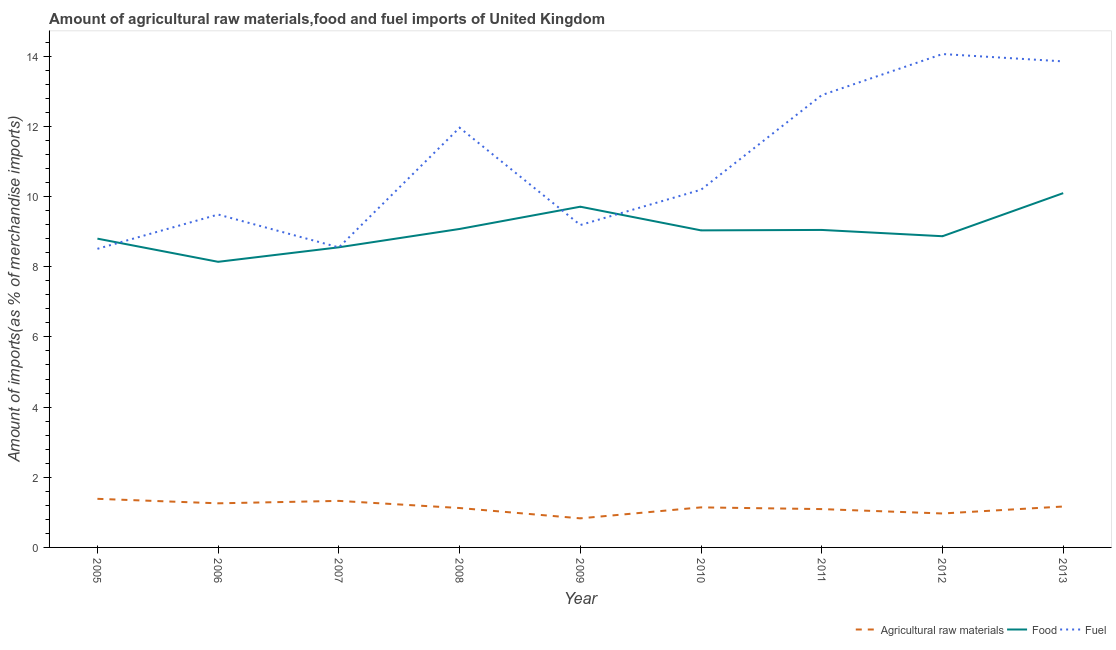Is the number of lines equal to the number of legend labels?
Keep it short and to the point. Yes. What is the percentage of food imports in 2007?
Your answer should be compact. 8.55. Across all years, what is the maximum percentage of food imports?
Keep it short and to the point. 10.1. Across all years, what is the minimum percentage of food imports?
Make the answer very short. 8.14. In which year was the percentage of food imports minimum?
Offer a very short reply. 2006. What is the total percentage of fuel imports in the graph?
Your response must be concise. 98.71. What is the difference between the percentage of food imports in 2006 and that in 2012?
Give a very brief answer. -0.73. What is the difference between the percentage of food imports in 2013 and the percentage of fuel imports in 2011?
Keep it short and to the point. -2.79. What is the average percentage of raw materials imports per year?
Provide a short and direct response. 1.14. In the year 2013, what is the difference between the percentage of raw materials imports and percentage of fuel imports?
Offer a very short reply. -12.69. In how many years, is the percentage of fuel imports greater than 2.8 %?
Provide a succinct answer. 9. What is the ratio of the percentage of food imports in 2010 to that in 2013?
Provide a succinct answer. 0.89. Is the percentage of fuel imports in 2007 less than that in 2008?
Provide a short and direct response. Yes. Is the difference between the percentage of fuel imports in 2009 and 2013 greater than the difference between the percentage of raw materials imports in 2009 and 2013?
Your answer should be compact. No. What is the difference between the highest and the second highest percentage of food imports?
Provide a succinct answer. 0.39. What is the difference between the highest and the lowest percentage of fuel imports?
Make the answer very short. 5.55. In how many years, is the percentage of fuel imports greater than the average percentage of fuel imports taken over all years?
Your answer should be compact. 4. Is the sum of the percentage of food imports in 2005 and 2007 greater than the maximum percentage of raw materials imports across all years?
Offer a very short reply. Yes. Is it the case that in every year, the sum of the percentage of raw materials imports and percentage of food imports is greater than the percentage of fuel imports?
Your answer should be very brief. No. How many lines are there?
Your response must be concise. 3. How many years are there in the graph?
Your response must be concise. 9. Does the graph contain grids?
Provide a short and direct response. No. How many legend labels are there?
Give a very brief answer. 3. What is the title of the graph?
Your answer should be very brief. Amount of agricultural raw materials,food and fuel imports of United Kingdom. What is the label or title of the X-axis?
Ensure brevity in your answer.  Year. What is the label or title of the Y-axis?
Provide a short and direct response. Amount of imports(as % of merchandise imports). What is the Amount of imports(as % of merchandise imports) of Agricultural raw materials in 2005?
Offer a very short reply. 1.39. What is the Amount of imports(as % of merchandise imports) of Food in 2005?
Make the answer very short. 8.8. What is the Amount of imports(as % of merchandise imports) of Fuel in 2005?
Give a very brief answer. 8.51. What is the Amount of imports(as % of merchandise imports) in Agricultural raw materials in 2006?
Keep it short and to the point. 1.26. What is the Amount of imports(as % of merchandise imports) of Food in 2006?
Your answer should be compact. 8.14. What is the Amount of imports(as % of merchandise imports) in Fuel in 2006?
Your answer should be compact. 9.49. What is the Amount of imports(as % of merchandise imports) in Agricultural raw materials in 2007?
Give a very brief answer. 1.33. What is the Amount of imports(as % of merchandise imports) of Food in 2007?
Keep it short and to the point. 8.55. What is the Amount of imports(as % of merchandise imports) in Fuel in 2007?
Your response must be concise. 8.55. What is the Amount of imports(as % of merchandise imports) of Agricultural raw materials in 2008?
Give a very brief answer. 1.12. What is the Amount of imports(as % of merchandise imports) of Food in 2008?
Keep it short and to the point. 9.08. What is the Amount of imports(as % of merchandise imports) of Fuel in 2008?
Ensure brevity in your answer.  11.96. What is the Amount of imports(as % of merchandise imports) in Agricultural raw materials in 2009?
Your response must be concise. 0.83. What is the Amount of imports(as % of merchandise imports) in Food in 2009?
Keep it short and to the point. 9.71. What is the Amount of imports(as % of merchandise imports) in Fuel in 2009?
Make the answer very short. 9.19. What is the Amount of imports(as % of merchandise imports) in Agricultural raw materials in 2010?
Give a very brief answer. 1.14. What is the Amount of imports(as % of merchandise imports) in Food in 2010?
Provide a succinct answer. 9.04. What is the Amount of imports(as % of merchandise imports) in Fuel in 2010?
Your response must be concise. 10.2. What is the Amount of imports(as % of merchandise imports) of Agricultural raw materials in 2011?
Give a very brief answer. 1.09. What is the Amount of imports(as % of merchandise imports) in Food in 2011?
Offer a terse response. 9.05. What is the Amount of imports(as % of merchandise imports) in Fuel in 2011?
Provide a succinct answer. 12.89. What is the Amount of imports(as % of merchandise imports) of Agricultural raw materials in 2012?
Keep it short and to the point. 0.97. What is the Amount of imports(as % of merchandise imports) in Food in 2012?
Make the answer very short. 8.87. What is the Amount of imports(as % of merchandise imports) in Fuel in 2012?
Your answer should be compact. 14.06. What is the Amount of imports(as % of merchandise imports) of Agricultural raw materials in 2013?
Provide a succinct answer. 1.17. What is the Amount of imports(as % of merchandise imports) in Food in 2013?
Offer a terse response. 10.1. What is the Amount of imports(as % of merchandise imports) in Fuel in 2013?
Provide a short and direct response. 13.85. Across all years, what is the maximum Amount of imports(as % of merchandise imports) in Agricultural raw materials?
Your response must be concise. 1.39. Across all years, what is the maximum Amount of imports(as % of merchandise imports) of Food?
Keep it short and to the point. 10.1. Across all years, what is the maximum Amount of imports(as % of merchandise imports) in Fuel?
Keep it short and to the point. 14.06. Across all years, what is the minimum Amount of imports(as % of merchandise imports) in Agricultural raw materials?
Your response must be concise. 0.83. Across all years, what is the minimum Amount of imports(as % of merchandise imports) of Food?
Provide a succinct answer. 8.14. Across all years, what is the minimum Amount of imports(as % of merchandise imports) in Fuel?
Give a very brief answer. 8.51. What is the total Amount of imports(as % of merchandise imports) in Agricultural raw materials in the graph?
Your response must be concise. 10.29. What is the total Amount of imports(as % of merchandise imports) of Food in the graph?
Make the answer very short. 81.34. What is the total Amount of imports(as % of merchandise imports) of Fuel in the graph?
Provide a short and direct response. 98.71. What is the difference between the Amount of imports(as % of merchandise imports) in Agricultural raw materials in 2005 and that in 2006?
Your answer should be compact. 0.13. What is the difference between the Amount of imports(as % of merchandise imports) in Food in 2005 and that in 2006?
Provide a succinct answer. 0.66. What is the difference between the Amount of imports(as % of merchandise imports) in Fuel in 2005 and that in 2006?
Your answer should be very brief. -0.98. What is the difference between the Amount of imports(as % of merchandise imports) of Agricultural raw materials in 2005 and that in 2007?
Provide a succinct answer. 0.06. What is the difference between the Amount of imports(as % of merchandise imports) in Food in 2005 and that in 2007?
Offer a terse response. 0.25. What is the difference between the Amount of imports(as % of merchandise imports) of Fuel in 2005 and that in 2007?
Provide a succinct answer. -0.04. What is the difference between the Amount of imports(as % of merchandise imports) in Agricultural raw materials in 2005 and that in 2008?
Your answer should be very brief. 0.26. What is the difference between the Amount of imports(as % of merchandise imports) in Food in 2005 and that in 2008?
Offer a terse response. -0.28. What is the difference between the Amount of imports(as % of merchandise imports) in Fuel in 2005 and that in 2008?
Provide a short and direct response. -3.45. What is the difference between the Amount of imports(as % of merchandise imports) in Agricultural raw materials in 2005 and that in 2009?
Keep it short and to the point. 0.56. What is the difference between the Amount of imports(as % of merchandise imports) of Food in 2005 and that in 2009?
Your answer should be very brief. -0.91. What is the difference between the Amount of imports(as % of merchandise imports) of Fuel in 2005 and that in 2009?
Offer a very short reply. -0.68. What is the difference between the Amount of imports(as % of merchandise imports) in Agricultural raw materials in 2005 and that in 2010?
Your answer should be very brief. 0.24. What is the difference between the Amount of imports(as % of merchandise imports) in Food in 2005 and that in 2010?
Your response must be concise. -0.24. What is the difference between the Amount of imports(as % of merchandise imports) in Fuel in 2005 and that in 2010?
Give a very brief answer. -1.68. What is the difference between the Amount of imports(as % of merchandise imports) in Agricultural raw materials in 2005 and that in 2011?
Provide a succinct answer. 0.29. What is the difference between the Amount of imports(as % of merchandise imports) of Food in 2005 and that in 2011?
Ensure brevity in your answer.  -0.25. What is the difference between the Amount of imports(as % of merchandise imports) of Fuel in 2005 and that in 2011?
Keep it short and to the point. -4.38. What is the difference between the Amount of imports(as % of merchandise imports) in Agricultural raw materials in 2005 and that in 2012?
Offer a terse response. 0.42. What is the difference between the Amount of imports(as % of merchandise imports) of Food in 2005 and that in 2012?
Your response must be concise. -0.07. What is the difference between the Amount of imports(as % of merchandise imports) in Fuel in 2005 and that in 2012?
Provide a short and direct response. -5.55. What is the difference between the Amount of imports(as % of merchandise imports) of Agricultural raw materials in 2005 and that in 2013?
Your answer should be very brief. 0.22. What is the difference between the Amount of imports(as % of merchandise imports) of Food in 2005 and that in 2013?
Give a very brief answer. -1.3. What is the difference between the Amount of imports(as % of merchandise imports) in Fuel in 2005 and that in 2013?
Give a very brief answer. -5.34. What is the difference between the Amount of imports(as % of merchandise imports) of Agricultural raw materials in 2006 and that in 2007?
Provide a short and direct response. -0.07. What is the difference between the Amount of imports(as % of merchandise imports) in Food in 2006 and that in 2007?
Provide a succinct answer. -0.41. What is the difference between the Amount of imports(as % of merchandise imports) in Fuel in 2006 and that in 2007?
Your response must be concise. 0.94. What is the difference between the Amount of imports(as % of merchandise imports) in Agricultural raw materials in 2006 and that in 2008?
Ensure brevity in your answer.  0.13. What is the difference between the Amount of imports(as % of merchandise imports) in Food in 2006 and that in 2008?
Offer a very short reply. -0.94. What is the difference between the Amount of imports(as % of merchandise imports) of Fuel in 2006 and that in 2008?
Give a very brief answer. -2.48. What is the difference between the Amount of imports(as % of merchandise imports) in Agricultural raw materials in 2006 and that in 2009?
Make the answer very short. 0.43. What is the difference between the Amount of imports(as % of merchandise imports) in Food in 2006 and that in 2009?
Offer a terse response. -1.57. What is the difference between the Amount of imports(as % of merchandise imports) of Fuel in 2006 and that in 2009?
Make the answer very short. 0.3. What is the difference between the Amount of imports(as % of merchandise imports) of Agricultural raw materials in 2006 and that in 2010?
Offer a terse response. 0.12. What is the difference between the Amount of imports(as % of merchandise imports) of Food in 2006 and that in 2010?
Make the answer very short. -0.9. What is the difference between the Amount of imports(as % of merchandise imports) in Fuel in 2006 and that in 2010?
Make the answer very short. -0.71. What is the difference between the Amount of imports(as % of merchandise imports) of Agricultural raw materials in 2006 and that in 2011?
Your answer should be compact. 0.16. What is the difference between the Amount of imports(as % of merchandise imports) in Food in 2006 and that in 2011?
Your answer should be compact. -0.91. What is the difference between the Amount of imports(as % of merchandise imports) in Fuel in 2006 and that in 2011?
Give a very brief answer. -3.4. What is the difference between the Amount of imports(as % of merchandise imports) of Agricultural raw materials in 2006 and that in 2012?
Provide a succinct answer. 0.29. What is the difference between the Amount of imports(as % of merchandise imports) of Food in 2006 and that in 2012?
Your answer should be very brief. -0.73. What is the difference between the Amount of imports(as % of merchandise imports) of Fuel in 2006 and that in 2012?
Keep it short and to the point. -4.57. What is the difference between the Amount of imports(as % of merchandise imports) of Agricultural raw materials in 2006 and that in 2013?
Your answer should be compact. 0.09. What is the difference between the Amount of imports(as % of merchandise imports) in Food in 2006 and that in 2013?
Ensure brevity in your answer.  -1.96. What is the difference between the Amount of imports(as % of merchandise imports) in Fuel in 2006 and that in 2013?
Your answer should be compact. -4.36. What is the difference between the Amount of imports(as % of merchandise imports) of Agricultural raw materials in 2007 and that in 2008?
Your response must be concise. 0.2. What is the difference between the Amount of imports(as % of merchandise imports) of Food in 2007 and that in 2008?
Ensure brevity in your answer.  -0.52. What is the difference between the Amount of imports(as % of merchandise imports) in Fuel in 2007 and that in 2008?
Provide a succinct answer. -3.41. What is the difference between the Amount of imports(as % of merchandise imports) in Agricultural raw materials in 2007 and that in 2009?
Provide a short and direct response. 0.5. What is the difference between the Amount of imports(as % of merchandise imports) in Food in 2007 and that in 2009?
Offer a very short reply. -1.16. What is the difference between the Amount of imports(as % of merchandise imports) of Fuel in 2007 and that in 2009?
Your answer should be very brief. -0.64. What is the difference between the Amount of imports(as % of merchandise imports) of Agricultural raw materials in 2007 and that in 2010?
Your answer should be very brief. 0.18. What is the difference between the Amount of imports(as % of merchandise imports) of Food in 2007 and that in 2010?
Provide a succinct answer. -0.48. What is the difference between the Amount of imports(as % of merchandise imports) in Fuel in 2007 and that in 2010?
Your answer should be compact. -1.64. What is the difference between the Amount of imports(as % of merchandise imports) of Agricultural raw materials in 2007 and that in 2011?
Offer a terse response. 0.23. What is the difference between the Amount of imports(as % of merchandise imports) of Food in 2007 and that in 2011?
Ensure brevity in your answer.  -0.5. What is the difference between the Amount of imports(as % of merchandise imports) in Fuel in 2007 and that in 2011?
Provide a short and direct response. -4.34. What is the difference between the Amount of imports(as % of merchandise imports) of Agricultural raw materials in 2007 and that in 2012?
Your response must be concise. 0.36. What is the difference between the Amount of imports(as % of merchandise imports) of Food in 2007 and that in 2012?
Make the answer very short. -0.32. What is the difference between the Amount of imports(as % of merchandise imports) of Fuel in 2007 and that in 2012?
Ensure brevity in your answer.  -5.51. What is the difference between the Amount of imports(as % of merchandise imports) of Agricultural raw materials in 2007 and that in 2013?
Your answer should be very brief. 0.16. What is the difference between the Amount of imports(as % of merchandise imports) of Food in 2007 and that in 2013?
Offer a terse response. -1.54. What is the difference between the Amount of imports(as % of merchandise imports) in Fuel in 2007 and that in 2013?
Ensure brevity in your answer.  -5.3. What is the difference between the Amount of imports(as % of merchandise imports) of Agricultural raw materials in 2008 and that in 2009?
Make the answer very short. 0.29. What is the difference between the Amount of imports(as % of merchandise imports) in Food in 2008 and that in 2009?
Give a very brief answer. -0.63. What is the difference between the Amount of imports(as % of merchandise imports) of Fuel in 2008 and that in 2009?
Offer a terse response. 2.77. What is the difference between the Amount of imports(as % of merchandise imports) of Agricultural raw materials in 2008 and that in 2010?
Your response must be concise. -0.02. What is the difference between the Amount of imports(as % of merchandise imports) in Food in 2008 and that in 2010?
Provide a succinct answer. 0.04. What is the difference between the Amount of imports(as % of merchandise imports) in Fuel in 2008 and that in 2010?
Give a very brief answer. 1.77. What is the difference between the Amount of imports(as % of merchandise imports) of Agricultural raw materials in 2008 and that in 2011?
Provide a short and direct response. 0.03. What is the difference between the Amount of imports(as % of merchandise imports) in Food in 2008 and that in 2011?
Provide a succinct answer. 0.03. What is the difference between the Amount of imports(as % of merchandise imports) of Fuel in 2008 and that in 2011?
Provide a short and direct response. -0.93. What is the difference between the Amount of imports(as % of merchandise imports) of Agricultural raw materials in 2008 and that in 2012?
Provide a short and direct response. 0.16. What is the difference between the Amount of imports(as % of merchandise imports) in Food in 2008 and that in 2012?
Your response must be concise. 0.21. What is the difference between the Amount of imports(as % of merchandise imports) of Fuel in 2008 and that in 2012?
Provide a short and direct response. -2.1. What is the difference between the Amount of imports(as % of merchandise imports) of Agricultural raw materials in 2008 and that in 2013?
Offer a very short reply. -0.04. What is the difference between the Amount of imports(as % of merchandise imports) in Food in 2008 and that in 2013?
Give a very brief answer. -1.02. What is the difference between the Amount of imports(as % of merchandise imports) of Fuel in 2008 and that in 2013?
Your answer should be compact. -1.89. What is the difference between the Amount of imports(as % of merchandise imports) in Agricultural raw materials in 2009 and that in 2010?
Give a very brief answer. -0.31. What is the difference between the Amount of imports(as % of merchandise imports) of Food in 2009 and that in 2010?
Give a very brief answer. 0.67. What is the difference between the Amount of imports(as % of merchandise imports) of Fuel in 2009 and that in 2010?
Offer a terse response. -1.01. What is the difference between the Amount of imports(as % of merchandise imports) in Agricultural raw materials in 2009 and that in 2011?
Your answer should be compact. -0.26. What is the difference between the Amount of imports(as % of merchandise imports) in Food in 2009 and that in 2011?
Make the answer very short. 0.66. What is the difference between the Amount of imports(as % of merchandise imports) in Fuel in 2009 and that in 2011?
Keep it short and to the point. -3.7. What is the difference between the Amount of imports(as % of merchandise imports) in Agricultural raw materials in 2009 and that in 2012?
Provide a succinct answer. -0.14. What is the difference between the Amount of imports(as % of merchandise imports) of Food in 2009 and that in 2012?
Offer a very short reply. 0.84. What is the difference between the Amount of imports(as % of merchandise imports) of Fuel in 2009 and that in 2012?
Give a very brief answer. -4.87. What is the difference between the Amount of imports(as % of merchandise imports) of Agricultural raw materials in 2009 and that in 2013?
Your answer should be very brief. -0.34. What is the difference between the Amount of imports(as % of merchandise imports) in Food in 2009 and that in 2013?
Your response must be concise. -0.39. What is the difference between the Amount of imports(as % of merchandise imports) in Fuel in 2009 and that in 2013?
Your response must be concise. -4.66. What is the difference between the Amount of imports(as % of merchandise imports) of Agricultural raw materials in 2010 and that in 2011?
Offer a very short reply. 0.05. What is the difference between the Amount of imports(as % of merchandise imports) of Food in 2010 and that in 2011?
Your response must be concise. -0.01. What is the difference between the Amount of imports(as % of merchandise imports) of Fuel in 2010 and that in 2011?
Offer a very short reply. -2.7. What is the difference between the Amount of imports(as % of merchandise imports) of Agricultural raw materials in 2010 and that in 2012?
Your answer should be very brief. 0.17. What is the difference between the Amount of imports(as % of merchandise imports) of Fuel in 2010 and that in 2012?
Make the answer very short. -3.87. What is the difference between the Amount of imports(as % of merchandise imports) of Agricultural raw materials in 2010 and that in 2013?
Your answer should be compact. -0.02. What is the difference between the Amount of imports(as % of merchandise imports) in Food in 2010 and that in 2013?
Your answer should be compact. -1.06. What is the difference between the Amount of imports(as % of merchandise imports) in Fuel in 2010 and that in 2013?
Offer a very short reply. -3.66. What is the difference between the Amount of imports(as % of merchandise imports) in Agricultural raw materials in 2011 and that in 2012?
Your answer should be very brief. 0.13. What is the difference between the Amount of imports(as % of merchandise imports) in Food in 2011 and that in 2012?
Provide a short and direct response. 0.18. What is the difference between the Amount of imports(as % of merchandise imports) of Fuel in 2011 and that in 2012?
Your response must be concise. -1.17. What is the difference between the Amount of imports(as % of merchandise imports) of Agricultural raw materials in 2011 and that in 2013?
Offer a very short reply. -0.07. What is the difference between the Amount of imports(as % of merchandise imports) of Food in 2011 and that in 2013?
Offer a very short reply. -1.05. What is the difference between the Amount of imports(as % of merchandise imports) in Fuel in 2011 and that in 2013?
Provide a short and direct response. -0.96. What is the difference between the Amount of imports(as % of merchandise imports) in Agricultural raw materials in 2012 and that in 2013?
Your answer should be very brief. -0.2. What is the difference between the Amount of imports(as % of merchandise imports) in Food in 2012 and that in 2013?
Your answer should be compact. -1.23. What is the difference between the Amount of imports(as % of merchandise imports) of Fuel in 2012 and that in 2013?
Provide a succinct answer. 0.21. What is the difference between the Amount of imports(as % of merchandise imports) in Agricultural raw materials in 2005 and the Amount of imports(as % of merchandise imports) in Food in 2006?
Provide a succinct answer. -6.76. What is the difference between the Amount of imports(as % of merchandise imports) of Agricultural raw materials in 2005 and the Amount of imports(as % of merchandise imports) of Fuel in 2006?
Provide a succinct answer. -8.1. What is the difference between the Amount of imports(as % of merchandise imports) of Food in 2005 and the Amount of imports(as % of merchandise imports) of Fuel in 2006?
Offer a very short reply. -0.69. What is the difference between the Amount of imports(as % of merchandise imports) in Agricultural raw materials in 2005 and the Amount of imports(as % of merchandise imports) in Food in 2007?
Your response must be concise. -7.17. What is the difference between the Amount of imports(as % of merchandise imports) of Agricultural raw materials in 2005 and the Amount of imports(as % of merchandise imports) of Fuel in 2007?
Ensure brevity in your answer.  -7.17. What is the difference between the Amount of imports(as % of merchandise imports) in Food in 2005 and the Amount of imports(as % of merchandise imports) in Fuel in 2007?
Provide a succinct answer. 0.25. What is the difference between the Amount of imports(as % of merchandise imports) in Agricultural raw materials in 2005 and the Amount of imports(as % of merchandise imports) in Food in 2008?
Offer a very short reply. -7.69. What is the difference between the Amount of imports(as % of merchandise imports) of Agricultural raw materials in 2005 and the Amount of imports(as % of merchandise imports) of Fuel in 2008?
Provide a succinct answer. -10.58. What is the difference between the Amount of imports(as % of merchandise imports) of Food in 2005 and the Amount of imports(as % of merchandise imports) of Fuel in 2008?
Make the answer very short. -3.16. What is the difference between the Amount of imports(as % of merchandise imports) in Agricultural raw materials in 2005 and the Amount of imports(as % of merchandise imports) in Food in 2009?
Give a very brief answer. -8.33. What is the difference between the Amount of imports(as % of merchandise imports) of Agricultural raw materials in 2005 and the Amount of imports(as % of merchandise imports) of Fuel in 2009?
Your answer should be compact. -7.8. What is the difference between the Amount of imports(as % of merchandise imports) in Food in 2005 and the Amount of imports(as % of merchandise imports) in Fuel in 2009?
Your response must be concise. -0.39. What is the difference between the Amount of imports(as % of merchandise imports) of Agricultural raw materials in 2005 and the Amount of imports(as % of merchandise imports) of Food in 2010?
Your response must be concise. -7.65. What is the difference between the Amount of imports(as % of merchandise imports) in Agricultural raw materials in 2005 and the Amount of imports(as % of merchandise imports) in Fuel in 2010?
Offer a terse response. -8.81. What is the difference between the Amount of imports(as % of merchandise imports) of Food in 2005 and the Amount of imports(as % of merchandise imports) of Fuel in 2010?
Keep it short and to the point. -1.39. What is the difference between the Amount of imports(as % of merchandise imports) in Agricultural raw materials in 2005 and the Amount of imports(as % of merchandise imports) in Food in 2011?
Offer a very short reply. -7.66. What is the difference between the Amount of imports(as % of merchandise imports) in Agricultural raw materials in 2005 and the Amount of imports(as % of merchandise imports) in Fuel in 2011?
Offer a very short reply. -11.51. What is the difference between the Amount of imports(as % of merchandise imports) of Food in 2005 and the Amount of imports(as % of merchandise imports) of Fuel in 2011?
Make the answer very short. -4.09. What is the difference between the Amount of imports(as % of merchandise imports) in Agricultural raw materials in 2005 and the Amount of imports(as % of merchandise imports) in Food in 2012?
Offer a very short reply. -7.49. What is the difference between the Amount of imports(as % of merchandise imports) in Agricultural raw materials in 2005 and the Amount of imports(as % of merchandise imports) in Fuel in 2012?
Give a very brief answer. -12.68. What is the difference between the Amount of imports(as % of merchandise imports) of Food in 2005 and the Amount of imports(as % of merchandise imports) of Fuel in 2012?
Offer a very short reply. -5.26. What is the difference between the Amount of imports(as % of merchandise imports) in Agricultural raw materials in 2005 and the Amount of imports(as % of merchandise imports) in Food in 2013?
Your response must be concise. -8.71. What is the difference between the Amount of imports(as % of merchandise imports) in Agricultural raw materials in 2005 and the Amount of imports(as % of merchandise imports) in Fuel in 2013?
Give a very brief answer. -12.47. What is the difference between the Amount of imports(as % of merchandise imports) in Food in 2005 and the Amount of imports(as % of merchandise imports) in Fuel in 2013?
Provide a short and direct response. -5.05. What is the difference between the Amount of imports(as % of merchandise imports) of Agricultural raw materials in 2006 and the Amount of imports(as % of merchandise imports) of Food in 2007?
Offer a terse response. -7.3. What is the difference between the Amount of imports(as % of merchandise imports) in Agricultural raw materials in 2006 and the Amount of imports(as % of merchandise imports) in Fuel in 2007?
Give a very brief answer. -7.29. What is the difference between the Amount of imports(as % of merchandise imports) in Food in 2006 and the Amount of imports(as % of merchandise imports) in Fuel in 2007?
Give a very brief answer. -0.41. What is the difference between the Amount of imports(as % of merchandise imports) in Agricultural raw materials in 2006 and the Amount of imports(as % of merchandise imports) in Food in 2008?
Provide a short and direct response. -7.82. What is the difference between the Amount of imports(as % of merchandise imports) of Agricultural raw materials in 2006 and the Amount of imports(as % of merchandise imports) of Fuel in 2008?
Keep it short and to the point. -10.71. What is the difference between the Amount of imports(as % of merchandise imports) of Food in 2006 and the Amount of imports(as % of merchandise imports) of Fuel in 2008?
Your response must be concise. -3.82. What is the difference between the Amount of imports(as % of merchandise imports) in Agricultural raw materials in 2006 and the Amount of imports(as % of merchandise imports) in Food in 2009?
Your response must be concise. -8.45. What is the difference between the Amount of imports(as % of merchandise imports) in Agricultural raw materials in 2006 and the Amount of imports(as % of merchandise imports) in Fuel in 2009?
Your response must be concise. -7.93. What is the difference between the Amount of imports(as % of merchandise imports) in Food in 2006 and the Amount of imports(as % of merchandise imports) in Fuel in 2009?
Ensure brevity in your answer.  -1.05. What is the difference between the Amount of imports(as % of merchandise imports) in Agricultural raw materials in 2006 and the Amount of imports(as % of merchandise imports) in Food in 2010?
Your answer should be compact. -7.78. What is the difference between the Amount of imports(as % of merchandise imports) of Agricultural raw materials in 2006 and the Amount of imports(as % of merchandise imports) of Fuel in 2010?
Offer a very short reply. -8.94. What is the difference between the Amount of imports(as % of merchandise imports) in Food in 2006 and the Amount of imports(as % of merchandise imports) in Fuel in 2010?
Offer a terse response. -2.06. What is the difference between the Amount of imports(as % of merchandise imports) of Agricultural raw materials in 2006 and the Amount of imports(as % of merchandise imports) of Food in 2011?
Give a very brief answer. -7.79. What is the difference between the Amount of imports(as % of merchandise imports) of Agricultural raw materials in 2006 and the Amount of imports(as % of merchandise imports) of Fuel in 2011?
Give a very brief answer. -11.64. What is the difference between the Amount of imports(as % of merchandise imports) in Food in 2006 and the Amount of imports(as % of merchandise imports) in Fuel in 2011?
Make the answer very short. -4.75. What is the difference between the Amount of imports(as % of merchandise imports) of Agricultural raw materials in 2006 and the Amount of imports(as % of merchandise imports) of Food in 2012?
Keep it short and to the point. -7.61. What is the difference between the Amount of imports(as % of merchandise imports) of Agricultural raw materials in 2006 and the Amount of imports(as % of merchandise imports) of Fuel in 2012?
Keep it short and to the point. -12.81. What is the difference between the Amount of imports(as % of merchandise imports) of Food in 2006 and the Amount of imports(as % of merchandise imports) of Fuel in 2012?
Provide a short and direct response. -5.92. What is the difference between the Amount of imports(as % of merchandise imports) in Agricultural raw materials in 2006 and the Amount of imports(as % of merchandise imports) in Food in 2013?
Make the answer very short. -8.84. What is the difference between the Amount of imports(as % of merchandise imports) in Agricultural raw materials in 2006 and the Amount of imports(as % of merchandise imports) in Fuel in 2013?
Provide a short and direct response. -12.6. What is the difference between the Amount of imports(as % of merchandise imports) in Food in 2006 and the Amount of imports(as % of merchandise imports) in Fuel in 2013?
Your response must be concise. -5.71. What is the difference between the Amount of imports(as % of merchandise imports) in Agricultural raw materials in 2007 and the Amount of imports(as % of merchandise imports) in Food in 2008?
Offer a terse response. -7.75. What is the difference between the Amount of imports(as % of merchandise imports) in Agricultural raw materials in 2007 and the Amount of imports(as % of merchandise imports) in Fuel in 2008?
Your answer should be very brief. -10.64. What is the difference between the Amount of imports(as % of merchandise imports) in Food in 2007 and the Amount of imports(as % of merchandise imports) in Fuel in 2008?
Offer a terse response. -3.41. What is the difference between the Amount of imports(as % of merchandise imports) in Agricultural raw materials in 2007 and the Amount of imports(as % of merchandise imports) in Food in 2009?
Your response must be concise. -8.39. What is the difference between the Amount of imports(as % of merchandise imports) of Agricultural raw materials in 2007 and the Amount of imports(as % of merchandise imports) of Fuel in 2009?
Your answer should be compact. -7.86. What is the difference between the Amount of imports(as % of merchandise imports) of Food in 2007 and the Amount of imports(as % of merchandise imports) of Fuel in 2009?
Keep it short and to the point. -0.63. What is the difference between the Amount of imports(as % of merchandise imports) in Agricultural raw materials in 2007 and the Amount of imports(as % of merchandise imports) in Food in 2010?
Offer a very short reply. -7.71. What is the difference between the Amount of imports(as % of merchandise imports) of Agricultural raw materials in 2007 and the Amount of imports(as % of merchandise imports) of Fuel in 2010?
Ensure brevity in your answer.  -8.87. What is the difference between the Amount of imports(as % of merchandise imports) in Food in 2007 and the Amount of imports(as % of merchandise imports) in Fuel in 2010?
Provide a succinct answer. -1.64. What is the difference between the Amount of imports(as % of merchandise imports) of Agricultural raw materials in 2007 and the Amount of imports(as % of merchandise imports) of Food in 2011?
Keep it short and to the point. -7.72. What is the difference between the Amount of imports(as % of merchandise imports) in Agricultural raw materials in 2007 and the Amount of imports(as % of merchandise imports) in Fuel in 2011?
Offer a very short reply. -11.57. What is the difference between the Amount of imports(as % of merchandise imports) in Food in 2007 and the Amount of imports(as % of merchandise imports) in Fuel in 2011?
Your answer should be very brief. -4.34. What is the difference between the Amount of imports(as % of merchandise imports) of Agricultural raw materials in 2007 and the Amount of imports(as % of merchandise imports) of Food in 2012?
Give a very brief answer. -7.54. What is the difference between the Amount of imports(as % of merchandise imports) in Agricultural raw materials in 2007 and the Amount of imports(as % of merchandise imports) in Fuel in 2012?
Provide a short and direct response. -12.74. What is the difference between the Amount of imports(as % of merchandise imports) of Food in 2007 and the Amount of imports(as % of merchandise imports) of Fuel in 2012?
Ensure brevity in your answer.  -5.51. What is the difference between the Amount of imports(as % of merchandise imports) of Agricultural raw materials in 2007 and the Amount of imports(as % of merchandise imports) of Food in 2013?
Ensure brevity in your answer.  -8.77. What is the difference between the Amount of imports(as % of merchandise imports) of Agricultural raw materials in 2007 and the Amount of imports(as % of merchandise imports) of Fuel in 2013?
Your answer should be compact. -12.53. What is the difference between the Amount of imports(as % of merchandise imports) in Food in 2007 and the Amount of imports(as % of merchandise imports) in Fuel in 2013?
Your answer should be very brief. -5.3. What is the difference between the Amount of imports(as % of merchandise imports) of Agricultural raw materials in 2008 and the Amount of imports(as % of merchandise imports) of Food in 2009?
Make the answer very short. -8.59. What is the difference between the Amount of imports(as % of merchandise imports) in Agricultural raw materials in 2008 and the Amount of imports(as % of merchandise imports) in Fuel in 2009?
Your answer should be very brief. -8.07. What is the difference between the Amount of imports(as % of merchandise imports) of Food in 2008 and the Amount of imports(as % of merchandise imports) of Fuel in 2009?
Give a very brief answer. -0.11. What is the difference between the Amount of imports(as % of merchandise imports) of Agricultural raw materials in 2008 and the Amount of imports(as % of merchandise imports) of Food in 2010?
Offer a very short reply. -7.91. What is the difference between the Amount of imports(as % of merchandise imports) of Agricultural raw materials in 2008 and the Amount of imports(as % of merchandise imports) of Fuel in 2010?
Keep it short and to the point. -9.07. What is the difference between the Amount of imports(as % of merchandise imports) of Food in 2008 and the Amount of imports(as % of merchandise imports) of Fuel in 2010?
Give a very brief answer. -1.12. What is the difference between the Amount of imports(as % of merchandise imports) in Agricultural raw materials in 2008 and the Amount of imports(as % of merchandise imports) in Food in 2011?
Keep it short and to the point. -7.93. What is the difference between the Amount of imports(as % of merchandise imports) of Agricultural raw materials in 2008 and the Amount of imports(as % of merchandise imports) of Fuel in 2011?
Keep it short and to the point. -11.77. What is the difference between the Amount of imports(as % of merchandise imports) in Food in 2008 and the Amount of imports(as % of merchandise imports) in Fuel in 2011?
Offer a very short reply. -3.82. What is the difference between the Amount of imports(as % of merchandise imports) in Agricultural raw materials in 2008 and the Amount of imports(as % of merchandise imports) in Food in 2012?
Give a very brief answer. -7.75. What is the difference between the Amount of imports(as % of merchandise imports) of Agricultural raw materials in 2008 and the Amount of imports(as % of merchandise imports) of Fuel in 2012?
Your response must be concise. -12.94. What is the difference between the Amount of imports(as % of merchandise imports) of Food in 2008 and the Amount of imports(as % of merchandise imports) of Fuel in 2012?
Your answer should be very brief. -4.99. What is the difference between the Amount of imports(as % of merchandise imports) of Agricultural raw materials in 2008 and the Amount of imports(as % of merchandise imports) of Food in 2013?
Your response must be concise. -8.98. What is the difference between the Amount of imports(as % of merchandise imports) of Agricultural raw materials in 2008 and the Amount of imports(as % of merchandise imports) of Fuel in 2013?
Your response must be concise. -12.73. What is the difference between the Amount of imports(as % of merchandise imports) of Food in 2008 and the Amount of imports(as % of merchandise imports) of Fuel in 2013?
Keep it short and to the point. -4.78. What is the difference between the Amount of imports(as % of merchandise imports) of Agricultural raw materials in 2009 and the Amount of imports(as % of merchandise imports) of Food in 2010?
Provide a succinct answer. -8.21. What is the difference between the Amount of imports(as % of merchandise imports) of Agricultural raw materials in 2009 and the Amount of imports(as % of merchandise imports) of Fuel in 2010?
Make the answer very short. -9.37. What is the difference between the Amount of imports(as % of merchandise imports) in Food in 2009 and the Amount of imports(as % of merchandise imports) in Fuel in 2010?
Provide a succinct answer. -0.48. What is the difference between the Amount of imports(as % of merchandise imports) of Agricultural raw materials in 2009 and the Amount of imports(as % of merchandise imports) of Food in 2011?
Ensure brevity in your answer.  -8.22. What is the difference between the Amount of imports(as % of merchandise imports) in Agricultural raw materials in 2009 and the Amount of imports(as % of merchandise imports) in Fuel in 2011?
Provide a short and direct response. -12.06. What is the difference between the Amount of imports(as % of merchandise imports) in Food in 2009 and the Amount of imports(as % of merchandise imports) in Fuel in 2011?
Make the answer very short. -3.18. What is the difference between the Amount of imports(as % of merchandise imports) in Agricultural raw materials in 2009 and the Amount of imports(as % of merchandise imports) in Food in 2012?
Ensure brevity in your answer.  -8.04. What is the difference between the Amount of imports(as % of merchandise imports) of Agricultural raw materials in 2009 and the Amount of imports(as % of merchandise imports) of Fuel in 2012?
Offer a terse response. -13.23. What is the difference between the Amount of imports(as % of merchandise imports) of Food in 2009 and the Amount of imports(as % of merchandise imports) of Fuel in 2012?
Give a very brief answer. -4.35. What is the difference between the Amount of imports(as % of merchandise imports) in Agricultural raw materials in 2009 and the Amount of imports(as % of merchandise imports) in Food in 2013?
Ensure brevity in your answer.  -9.27. What is the difference between the Amount of imports(as % of merchandise imports) in Agricultural raw materials in 2009 and the Amount of imports(as % of merchandise imports) in Fuel in 2013?
Offer a terse response. -13.02. What is the difference between the Amount of imports(as % of merchandise imports) of Food in 2009 and the Amount of imports(as % of merchandise imports) of Fuel in 2013?
Provide a short and direct response. -4.14. What is the difference between the Amount of imports(as % of merchandise imports) of Agricultural raw materials in 2010 and the Amount of imports(as % of merchandise imports) of Food in 2011?
Offer a terse response. -7.91. What is the difference between the Amount of imports(as % of merchandise imports) in Agricultural raw materials in 2010 and the Amount of imports(as % of merchandise imports) in Fuel in 2011?
Provide a succinct answer. -11.75. What is the difference between the Amount of imports(as % of merchandise imports) of Food in 2010 and the Amount of imports(as % of merchandise imports) of Fuel in 2011?
Ensure brevity in your answer.  -3.86. What is the difference between the Amount of imports(as % of merchandise imports) in Agricultural raw materials in 2010 and the Amount of imports(as % of merchandise imports) in Food in 2012?
Provide a succinct answer. -7.73. What is the difference between the Amount of imports(as % of merchandise imports) in Agricultural raw materials in 2010 and the Amount of imports(as % of merchandise imports) in Fuel in 2012?
Keep it short and to the point. -12.92. What is the difference between the Amount of imports(as % of merchandise imports) of Food in 2010 and the Amount of imports(as % of merchandise imports) of Fuel in 2012?
Keep it short and to the point. -5.03. What is the difference between the Amount of imports(as % of merchandise imports) in Agricultural raw materials in 2010 and the Amount of imports(as % of merchandise imports) in Food in 2013?
Make the answer very short. -8.96. What is the difference between the Amount of imports(as % of merchandise imports) in Agricultural raw materials in 2010 and the Amount of imports(as % of merchandise imports) in Fuel in 2013?
Your response must be concise. -12.71. What is the difference between the Amount of imports(as % of merchandise imports) in Food in 2010 and the Amount of imports(as % of merchandise imports) in Fuel in 2013?
Your answer should be very brief. -4.82. What is the difference between the Amount of imports(as % of merchandise imports) of Agricultural raw materials in 2011 and the Amount of imports(as % of merchandise imports) of Food in 2012?
Your answer should be compact. -7.78. What is the difference between the Amount of imports(as % of merchandise imports) of Agricultural raw materials in 2011 and the Amount of imports(as % of merchandise imports) of Fuel in 2012?
Offer a very short reply. -12.97. What is the difference between the Amount of imports(as % of merchandise imports) in Food in 2011 and the Amount of imports(as % of merchandise imports) in Fuel in 2012?
Give a very brief answer. -5.01. What is the difference between the Amount of imports(as % of merchandise imports) of Agricultural raw materials in 2011 and the Amount of imports(as % of merchandise imports) of Food in 2013?
Your answer should be compact. -9.01. What is the difference between the Amount of imports(as % of merchandise imports) of Agricultural raw materials in 2011 and the Amount of imports(as % of merchandise imports) of Fuel in 2013?
Give a very brief answer. -12.76. What is the difference between the Amount of imports(as % of merchandise imports) of Food in 2011 and the Amount of imports(as % of merchandise imports) of Fuel in 2013?
Your answer should be compact. -4.8. What is the difference between the Amount of imports(as % of merchandise imports) of Agricultural raw materials in 2012 and the Amount of imports(as % of merchandise imports) of Food in 2013?
Give a very brief answer. -9.13. What is the difference between the Amount of imports(as % of merchandise imports) in Agricultural raw materials in 2012 and the Amount of imports(as % of merchandise imports) in Fuel in 2013?
Provide a succinct answer. -12.89. What is the difference between the Amount of imports(as % of merchandise imports) in Food in 2012 and the Amount of imports(as % of merchandise imports) in Fuel in 2013?
Offer a very short reply. -4.98. What is the average Amount of imports(as % of merchandise imports) in Agricultural raw materials per year?
Provide a succinct answer. 1.14. What is the average Amount of imports(as % of merchandise imports) of Food per year?
Provide a succinct answer. 9.04. What is the average Amount of imports(as % of merchandise imports) in Fuel per year?
Ensure brevity in your answer.  10.97. In the year 2005, what is the difference between the Amount of imports(as % of merchandise imports) of Agricultural raw materials and Amount of imports(as % of merchandise imports) of Food?
Offer a very short reply. -7.42. In the year 2005, what is the difference between the Amount of imports(as % of merchandise imports) in Agricultural raw materials and Amount of imports(as % of merchandise imports) in Fuel?
Your answer should be very brief. -7.13. In the year 2005, what is the difference between the Amount of imports(as % of merchandise imports) in Food and Amount of imports(as % of merchandise imports) in Fuel?
Give a very brief answer. 0.29. In the year 2006, what is the difference between the Amount of imports(as % of merchandise imports) in Agricultural raw materials and Amount of imports(as % of merchandise imports) in Food?
Give a very brief answer. -6.88. In the year 2006, what is the difference between the Amount of imports(as % of merchandise imports) in Agricultural raw materials and Amount of imports(as % of merchandise imports) in Fuel?
Offer a terse response. -8.23. In the year 2006, what is the difference between the Amount of imports(as % of merchandise imports) of Food and Amount of imports(as % of merchandise imports) of Fuel?
Your answer should be very brief. -1.35. In the year 2007, what is the difference between the Amount of imports(as % of merchandise imports) of Agricultural raw materials and Amount of imports(as % of merchandise imports) of Food?
Provide a succinct answer. -7.23. In the year 2007, what is the difference between the Amount of imports(as % of merchandise imports) of Agricultural raw materials and Amount of imports(as % of merchandise imports) of Fuel?
Make the answer very short. -7.22. In the year 2007, what is the difference between the Amount of imports(as % of merchandise imports) of Food and Amount of imports(as % of merchandise imports) of Fuel?
Your response must be concise. 0. In the year 2008, what is the difference between the Amount of imports(as % of merchandise imports) of Agricultural raw materials and Amount of imports(as % of merchandise imports) of Food?
Ensure brevity in your answer.  -7.95. In the year 2008, what is the difference between the Amount of imports(as % of merchandise imports) in Agricultural raw materials and Amount of imports(as % of merchandise imports) in Fuel?
Provide a short and direct response. -10.84. In the year 2008, what is the difference between the Amount of imports(as % of merchandise imports) in Food and Amount of imports(as % of merchandise imports) in Fuel?
Offer a very short reply. -2.89. In the year 2009, what is the difference between the Amount of imports(as % of merchandise imports) of Agricultural raw materials and Amount of imports(as % of merchandise imports) of Food?
Keep it short and to the point. -8.88. In the year 2009, what is the difference between the Amount of imports(as % of merchandise imports) of Agricultural raw materials and Amount of imports(as % of merchandise imports) of Fuel?
Offer a very short reply. -8.36. In the year 2009, what is the difference between the Amount of imports(as % of merchandise imports) of Food and Amount of imports(as % of merchandise imports) of Fuel?
Provide a short and direct response. 0.52. In the year 2010, what is the difference between the Amount of imports(as % of merchandise imports) in Agricultural raw materials and Amount of imports(as % of merchandise imports) in Food?
Your response must be concise. -7.9. In the year 2010, what is the difference between the Amount of imports(as % of merchandise imports) in Agricultural raw materials and Amount of imports(as % of merchandise imports) in Fuel?
Your answer should be very brief. -9.05. In the year 2010, what is the difference between the Amount of imports(as % of merchandise imports) in Food and Amount of imports(as % of merchandise imports) in Fuel?
Provide a succinct answer. -1.16. In the year 2011, what is the difference between the Amount of imports(as % of merchandise imports) of Agricultural raw materials and Amount of imports(as % of merchandise imports) of Food?
Provide a succinct answer. -7.96. In the year 2011, what is the difference between the Amount of imports(as % of merchandise imports) in Agricultural raw materials and Amount of imports(as % of merchandise imports) in Fuel?
Give a very brief answer. -11.8. In the year 2011, what is the difference between the Amount of imports(as % of merchandise imports) in Food and Amount of imports(as % of merchandise imports) in Fuel?
Offer a terse response. -3.84. In the year 2012, what is the difference between the Amount of imports(as % of merchandise imports) in Agricultural raw materials and Amount of imports(as % of merchandise imports) in Food?
Provide a succinct answer. -7.9. In the year 2012, what is the difference between the Amount of imports(as % of merchandise imports) of Agricultural raw materials and Amount of imports(as % of merchandise imports) of Fuel?
Provide a short and direct response. -13.1. In the year 2012, what is the difference between the Amount of imports(as % of merchandise imports) in Food and Amount of imports(as % of merchandise imports) in Fuel?
Your response must be concise. -5.19. In the year 2013, what is the difference between the Amount of imports(as % of merchandise imports) of Agricultural raw materials and Amount of imports(as % of merchandise imports) of Food?
Keep it short and to the point. -8.93. In the year 2013, what is the difference between the Amount of imports(as % of merchandise imports) of Agricultural raw materials and Amount of imports(as % of merchandise imports) of Fuel?
Provide a succinct answer. -12.69. In the year 2013, what is the difference between the Amount of imports(as % of merchandise imports) of Food and Amount of imports(as % of merchandise imports) of Fuel?
Your answer should be compact. -3.76. What is the ratio of the Amount of imports(as % of merchandise imports) in Agricultural raw materials in 2005 to that in 2006?
Ensure brevity in your answer.  1.1. What is the ratio of the Amount of imports(as % of merchandise imports) of Food in 2005 to that in 2006?
Offer a very short reply. 1.08. What is the ratio of the Amount of imports(as % of merchandise imports) of Fuel in 2005 to that in 2006?
Ensure brevity in your answer.  0.9. What is the ratio of the Amount of imports(as % of merchandise imports) of Agricultural raw materials in 2005 to that in 2007?
Give a very brief answer. 1.04. What is the ratio of the Amount of imports(as % of merchandise imports) in Food in 2005 to that in 2007?
Make the answer very short. 1.03. What is the ratio of the Amount of imports(as % of merchandise imports) of Fuel in 2005 to that in 2007?
Keep it short and to the point. 1. What is the ratio of the Amount of imports(as % of merchandise imports) of Agricultural raw materials in 2005 to that in 2008?
Your answer should be compact. 1.23. What is the ratio of the Amount of imports(as % of merchandise imports) in Food in 2005 to that in 2008?
Offer a terse response. 0.97. What is the ratio of the Amount of imports(as % of merchandise imports) in Fuel in 2005 to that in 2008?
Give a very brief answer. 0.71. What is the ratio of the Amount of imports(as % of merchandise imports) of Agricultural raw materials in 2005 to that in 2009?
Provide a succinct answer. 1.67. What is the ratio of the Amount of imports(as % of merchandise imports) of Food in 2005 to that in 2009?
Offer a terse response. 0.91. What is the ratio of the Amount of imports(as % of merchandise imports) of Fuel in 2005 to that in 2009?
Give a very brief answer. 0.93. What is the ratio of the Amount of imports(as % of merchandise imports) in Agricultural raw materials in 2005 to that in 2010?
Keep it short and to the point. 1.21. What is the ratio of the Amount of imports(as % of merchandise imports) of Food in 2005 to that in 2010?
Ensure brevity in your answer.  0.97. What is the ratio of the Amount of imports(as % of merchandise imports) of Fuel in 2005 to that in 2010?
Your answer should be compact. 0.83. What is the ratio of the Amount of imports(as % of merchandise imports) in Agricultural raw materials in 2005 to that in 2011?
Provide a succinct answer. 1.27. What is the ratio of the Amount of imports(as % of merchandise imports) in Food in 2005 to that in 2011?
Ensure brevity in your answer.  0.97. What is the ratio of the Amount of imports(as % of merchandise imports) of Fuel in 2005 to that in 2011?
Give a very brief answer. 0.66. What is the ratio of the Amount of imports(as % of merchandise imports) in Agricultural raw materials in 2005 to that in 2012?
Give a very brief answer. 1.43. What is the ratio of the Amount of imports(as % of merchandise imports) in Fuel in 2005 to that in 2012?
Your answer should be compact. 0.61. What is the ratio of the Amount of imports(as % of merchandise imports) of Agricultural raw materials in 2005 to that in 2013?
Provide a short and direct response. 1.19. What is the ratio of the Amount of imports(as % of merchandise imports) of Food in 2005 to that in 2013?
Offer a very short reply. 0.87. What is the ratio of the Amount of imports(as % of merchandise imports) of Fuel in 2005 to that in 2013?
Offer a terse response. 0.61. What is the ratio of the Amount of imports(as % of merchandise imports) in Agricultural raw materials in 2006 to that in 2007?
Provide a succinct answer. 0.95. What is the ratio of the Amount of imports(as % of merchandise imports) in Food in 2006 to that in 2007?
Provide a short and direct response. 0.95. What is the ratio of the Amount of imports(as % of merchandise imports) of Fuel in 2006 to that in 2007?
Your answer should be compact. 1.11. What is the ratio of the Amount of imports(as % of merchandise imports) in Agricultural raw materials in 2006 to that in 2008?
Offer a terse response. 1.12. What is the ratio of the Amount of imports(as % of merchandise imports) in Food in 2006 to that in 2008?
Ensure brevity in your answer.  0.9. What is the ratio of the Amount of imports(as % of merchandise imports) of Fuel in 2006 to that in 2008?
Keep it short and to the point. 0.79. What is the ratio of the Amount of imports(as % of merchandise imports) in Agricultural raw materials in 2006 to that in 2009?
Provide a short and direct response. 1.52. What is the ratio of the Amount of imports(as % of merchandise imports) of Food in 2006 to that in 2009?
Keep it short and to the point. 0.84. What is the ratio of the Amount of imports(as % of merchandise imports) of Fuel in 2006 to that in 2009?
Provide a short and direct response. 1.03. What is the ratio of the Amount of imports(as % of merchandise imports) in Agricultural raw materials in 2006 to that in 2010?
Provide a short and direct response. 1.1. What is the ratio of the Amount of imports(as % of merchandise imports) of Food in 2006 to that in 2010?
Your answer should be very brief. 0.9. What is the ratio of the Amount of imports(as % of merchandise imports) of Fuel in 2006 to that in 2010?
Make the answer very short. 0.93. What is the ratio of the Amount of imports(as % of merchandise imports) in Agricultural raw materials in 2006 to that in 2011?
Offer a very short reply. 1.15. What is the ratio of the Amount of imports(as % of merchandise imports) of Food in 2006 to that in 2011?
Your answer should be very brief. 0.9. What is the ratio of the Amount of imports(as % of merchandise imports) in Fuel in 2006 to that in 2011?
Your response must be concise. 0.74. What is the ratio of the Amount of imports(as % of merchandise imports) of Agricultural raw materials in 2006 to that in 2012?
Your answer should be compact. 1.3. What is the ratio of the Amount of imports(as % of merchandise imports) in Food in 2006 to that in 2012?
Keep it short and to the point. 0.92. What is the ratio of the Amount of imports(as % of merchandise imports) in Fuel in 2006 to that in 2012?
Your answer should be compact. 0.67. What is the ratio of the Amount of imports(as % of merchandise imports) of Agricultural raw materials in 2006 to that in 2013?
Your answer should be very brief. 1.08. What is the ratio of the Amount of imports(as % of merchandise imports) in Food in 2006 to that in 2013?
Your answer should be very brief. 0.81. What is the ratio of the Amount of imports(as % of merchandise imports) of Fuel in 2006 to that in 2013?
Give a very brief answer. 0.68. What is the ratio of the Amount of imports(as % of merchandise imports) of Agricultural raw materials in 2007 to that in 2008?
Provide a short and direct response. 1.18. What is the ratio of the Amount of imports(as % of merchandise imports) of Food in 2007 to that in 2008?
Make the answer very short. 0.94. What is the ratio of the Amount of imports(as % of merchandise imports) of Fuel in 2007 to that in 2008?
Ensure brevity in your answer.  0.71. What is the ratio of the Amount of imports(as % of merchandise imports) in Agricultural raw materials in 2007 to that in 2009?
Offer a very short reply. 1.6. What is the ratio of the Amount of imports(as % of merchandise imports) in Food in 2007 to that in 2009?
Offer a very short reply. 0.88. What is the ratio of the Amount of imports(as % of merchandise imports) of Fuel in 2007 to that in 2009?
Keep it short and to the point. 0.93. What is the ratio of the Amount of imports(as % of merchandise imports) in Agricultural raw materials in 2007 to that in 2010?
Give a very brief answer. 1.16. What is the ratio of the Amount of imports(as % of merchandise imports) of Food in 2007 to that in 2010?
Offer a terse response. 0.95. What is the ratio of the Amount of imports(as % of merchandise imports) in Fuel in 2007 to that in 2010?
Provide a succinct answer. 0.84. What is the ratio of the Amount of imports(as % of merchandise imports) in Agricultural raw materials in 2007 to that in 2011?
Ensure brevity in your answer.  1.21. What is the ratio of the Amount of imports(as % of merchandise imports) in Food in 2007 to that in 2011?
Provide a succinct answer. 0.95. What is the ratio of the Amount of imports(as % of merchandise imports) of Fuel in 2007 to that in 2011?
Ensure brevity in your answer.  0.66. What is the ratio of the Amount of imports(as % of merchandise imports) in Agricultural raw materials in 2007 to that in 2012?
Ensure brevity in your answer.  1.37. What is the ratio of the Amount of imports(as % of merchandise imports) in Food in 2007 to that in 2012?
Keep it short and to the point. 0.96. What is the ratio of the Amount of imports(as % of merchandise imports) in Fuel in 2007 to that in 2012?
Your answer should be very brief. 0.61. What is the ratio of the Amount of imports(as % of merchandise imports) of Agricultural raw materials in 2007 to that in 2013?
Keep it short and to the point. 1.14. What is the ratio of the Amount of imports(as % of merchandise imports) of Food in 2007 to that in 2013?
Offer a terse response. 0.85. What is the ratio of the Amount of imports(as % of merchandise imports) in Fuel in 2007 to that in 2013?
Offer a terse response. 0.62. What is the ratio of the Amount of imports(as % of merchandise imports) in Agricultural raw materials in 2008 to that in 2009?
Your response must be concise. 1.35. What is the ratio of the Amount of imports(as % of merchandise imports) in Food in 2008 to that in 2009?
Give a very brief answer. 0.93. What is the ratio of the Amount of imports(as % of merchandise imports) of Fuel in 2008 to that in 2009?
Your answer should be compact. 1.3. What is the ratio of the Amount of imports(as % of merchandise imports) of Agricultural raw materials in 2008 to that in 2010?
Offer a terse response. 0.98. What is the ratio of the Amount of imports(as % of merchandise imports) in Fuel in 2008 to that in 2010?
Offer a terse response. 1.17. What is the ratio of the Amount of imports(as % of merchandise imports) of Agricultural raw materials in 2008 to that in 2011?
Offer a very short reply. 1.03. What is the ratio of the Amount of imports(as % of merchandise imports) of Food in 2008 to that in 2011?
Offer a terse response. 1. What is the ratio of the Amount of imports(as % of merchandise imports) in Fuel in 2008 to that in 2011?
Your response must be concise. 0.93. What is the ratio of the Amount of imports(as % of merchandise imports) of Agricultural raw materials in 2008 to that in 2012?
Your answer should be very brief. 1.16. What is the ratio of the Amount of imports(as % of merchandise imports) of Food in 2008 to that in 2012?
Your answer should be compact. 1.02. What is the ratio of the Amount of imports(as % of merchandise imports) of Fuel in 2008 to that in 2012?
Keep it short and to the point. 0.85. What is the ratio of the Amount of imports(as % of merchandise imports) in Agricultural raw materials in 2008 to that in 2013?
Your response must be concise. 0.96. What is the ratio of the Amount of imports(as % of merchandise imports) in Food in 2008 to that in 2013?
Your answer should be compact. 0.9. What is the ratio of the Amount of imports(as % of merchandise imports) in Fuel in 2008 to that in 2013?
Give a very brief answer. 0.86. What is the ratio of the Amount of imports(as % of merchandise imports) in Agricultural raw materials in 2009 to that in 2010?
Your response must be concise. 0.73. What is the ratio of the Amount of imports(as % of merchandise imports) of Food in 2009 to that in 2010?
Make the answer very short. 1.07. What is the ratio of the Amount of imports(as % of merchandise imports) in Fuel in 2009 to that in 2010?
Make the answer very short. 0.9. What is the ratio of the Amount of imports(as % of merchandise imports) in Agricultural raw materials in 2009 to that in 2011?
Provide a short and direct response. 0.76. What is the ratio of the Amount of imports(as % of merchandise imports) in Food in 2009 to that in 2011?
Your answer should be very brief. 1.07. What is the ratio of the Amount of imports(as % of merchandise imports) in Fuel in 2009 to that in 2011?
Your response must be concise. 0.71. What is the ratio of the Amount of imports(as % of merchandise imports) of Agricultural raw materials in 2009 to that in 2012?
Keep it short and to the point. 0.86. What is the ratio of the Amount of imports(as % of merchandise imports) of Food in 2009 to that in 2012?
Your response must be concise. 1.09. What is the ratio of the Amount of imports(as % of merchandise imports) of Fuel in 2009 to that in 2012?
Offer a terse response. 0.65. What is the ratio of the Amount of imports(as % of merchandise imports) of Agricultural raw materials in 2009 to that in 2013?
Provide a short and direct response. 0.71. What is the ratio of the Amount of imports(as % of merchandise imports) of Food in 2009 to that in 2013?
Give a very brief answer. 0.96. What is the ratio of the Amount of imports(as % of merchandise imports) in Fuel in 2009 to that in 2013?
Give a very brief answer. 0.66. What is the ratio of the Amount of imports(as % of merchandise imports) of Agricultural raw materials in 2010 to that in 2011?
Offer a terse response. 1.04. What is the ratio of the Amount of imports(as % of merchandise imports) in Fuel in 2010 to that in 2011?
Your answer should be compact. 0.79. What is the ratio of the Amount of imports(as % of merchandise imports) of Agricultural raw materials in 2010 to that in 2012?
Provide a short and direct response. 1.18. What is the ratio of the Amount of imports(as % of merchandise imports) in Food in 2010 to that in 2012?
Ensure brevity in your answer.  1.02. What is the ratio of the Amount of imports(as % of merchandise imports) in Fuel in 2010 to that in 2012?
Make the answer very short. 0.72. What is the ratio of the Amount of imports(as % of merchandise imports) in Food in 2010 to that in 2013?
Offer a very short reply. 0.89. What is the ratio of the Amount of imports(as % of merchandise imports) of Fuel in 2010 to that in 2013?
Provide a short and direct response. 0.74. What is the ratio of the Amount of imports(as % of merchandise imports) of Agricultural raw materials in 2011 to that in 2012?
Your answer should be very brief. 1.13. What is the ratio of the Amount of imports(as % of merchandise imports) in Food in 2011 to that in 2012?
Give a very brief answer. 1.02. What is the ratio of the Amount of imports(as % of merchandise imports) of Fuel in 2011 to that in 2012?
Your answer should be very brief. 0.92. What is the ratio of the Amount of imports(as % of merchandise imports) of Agricultural raw materials in 2011 to that in 2013?
Ensure brevity in your answer.  0.94. What is the ratio of the Amount of imports(as % of merchandise imports) in Food in 2011 to that in 2013?
Ensure brevity in your answer.  0.9. What is the ratio of the Amount of imports(as % of merchandise imports) in Fuel in 2011 to that in 2013?
Your response must be concise. 0.93. What is the ratio of the Amount of imports(as % of merchandise imports) in Agricultural raw materials in 2012 to that in 2013?
Provide a succinct answer. 0.83. What is the ratio of the Amount of imports(as % of merchandise imports) in Food in 2012 to that in 2013?
Offer a terse response. 0.88. What is the ratio of the Amount of imports(as % of merchandise imports) of Fuel in 2012 to that in 2013?
Ensure brevity in your answer.  1.02. What is the difference between the highest and the second highest Amount of imports(as % of merchandise imports) of Agricultural raw materials?
Provide a short and direct response. 0.06. What is the difference between the highest and the second highest Amount of imports(as % of merchandise imports) of Food?
Your answer should be very brief. 0.39. What is the difference between the highest and the second highest Amount of imports(as % of merchandise imports) of Fuel?
Offer a very short reply. 0.21. What is the difference between the highest and the lowest Amount of imports(as % of merchandise imports) in Agricultural raw materials?
Provide a succinct answer. 0.56. What is the difference between the highest and the lowest Amount of imports(as % of merchandise imports) in Food?
Give a very brief answer. 1.96. What is the difference between the highest and the lowest Amount of imports(as % of merchandise imports) of Fuel?
Your answer should be very brief. 5.55. 